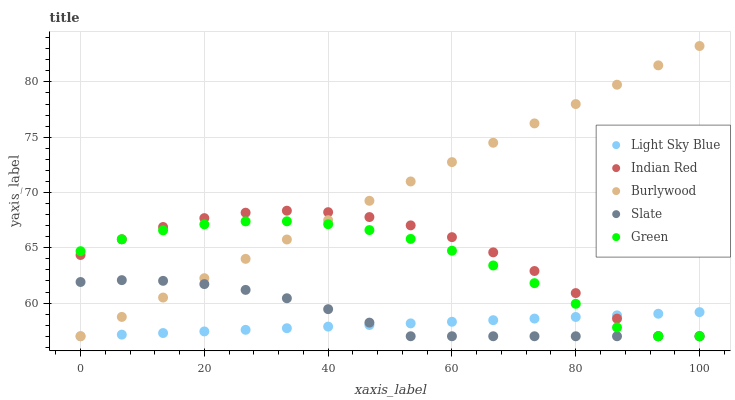Does Light Sky Blue have the minimum area under the curve?
Answer yes or no. Yes. Does Burlywood have the maximum area under the curve?
Answer yes or no. Yes. Does Slate have the minimum area under the curve?
Answer yes or no. No. Does Slate have the maximum area under the curve?
Answer yes or no. No. Is Light Sky Blue the smoothest?
Answer yes or no. Yes. Is Indian Red the roughest?
Answer yes or no. Yes. Is Slate the smoothest?
Answer yes or no. No. Is Slate the roughest?
Answer yes or no. No. Does Burlywood have the lowest value?
Answer yes or no. Yes. Does Burlywood have the highest value?
Answer yes or no. Yes. Does Slate have the highest value?
Answer yes or no. No. Does Indian Red intersect Burlywood?
Answer yes or no. Yes. Is Indian Red less than Burlywood?
Answer yes or no. No. Is Indian Red greater than Burlywood?
Answer yes or no. No. 